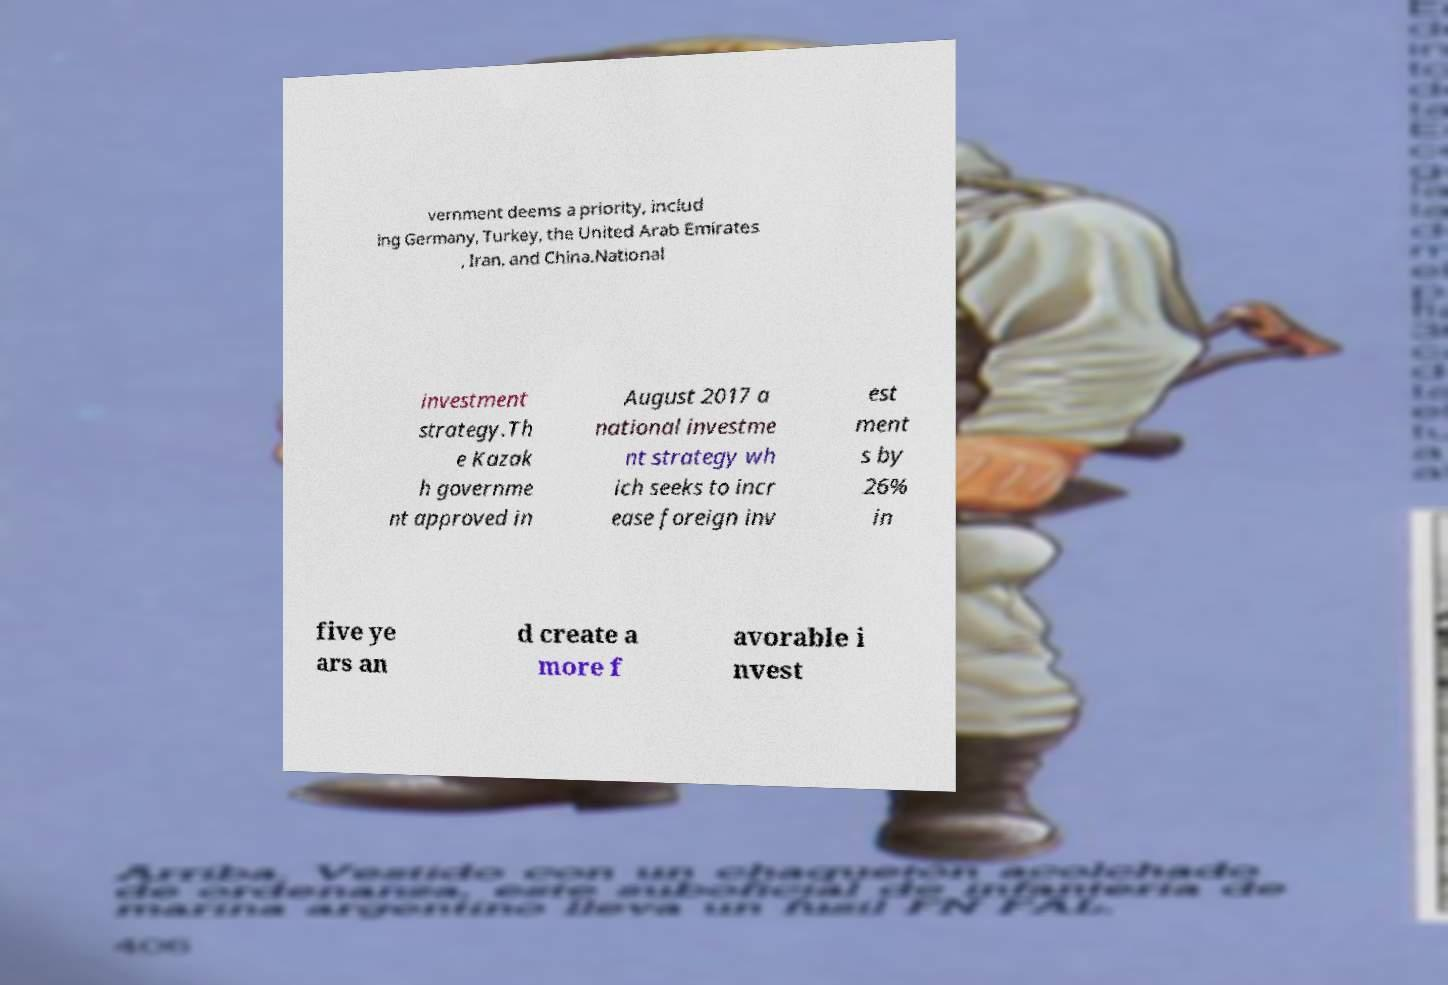Please identify and transcribe the text found in this image. vernment deems a priority, includ ing Germany, Turkey, the United Arab Emirates , Iran, and China.National investment strategy.Th e Kazak h governme nt approved in August 2017 a national investme nt strategy wh ich seeks to incr ease foreign inv est ment s by 26% in five ye ars an d create a more f avorable i nvest 